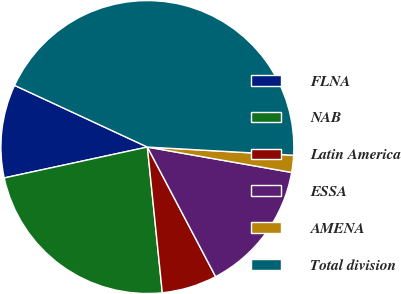<chart> <loc_0><loc_0><loc_500><loc_500><pie_chart><fcel>FLNA<fcel>NAB<fcel>Latin America<fcel>ESSA<fcel>AMENA<fcel>Total division<nl><fcel>10.3%<fcel>23.24%<fcel>6.09%<fcel>14.51%<fcel>1.88%<fcel>43.97%<nl></chart> 